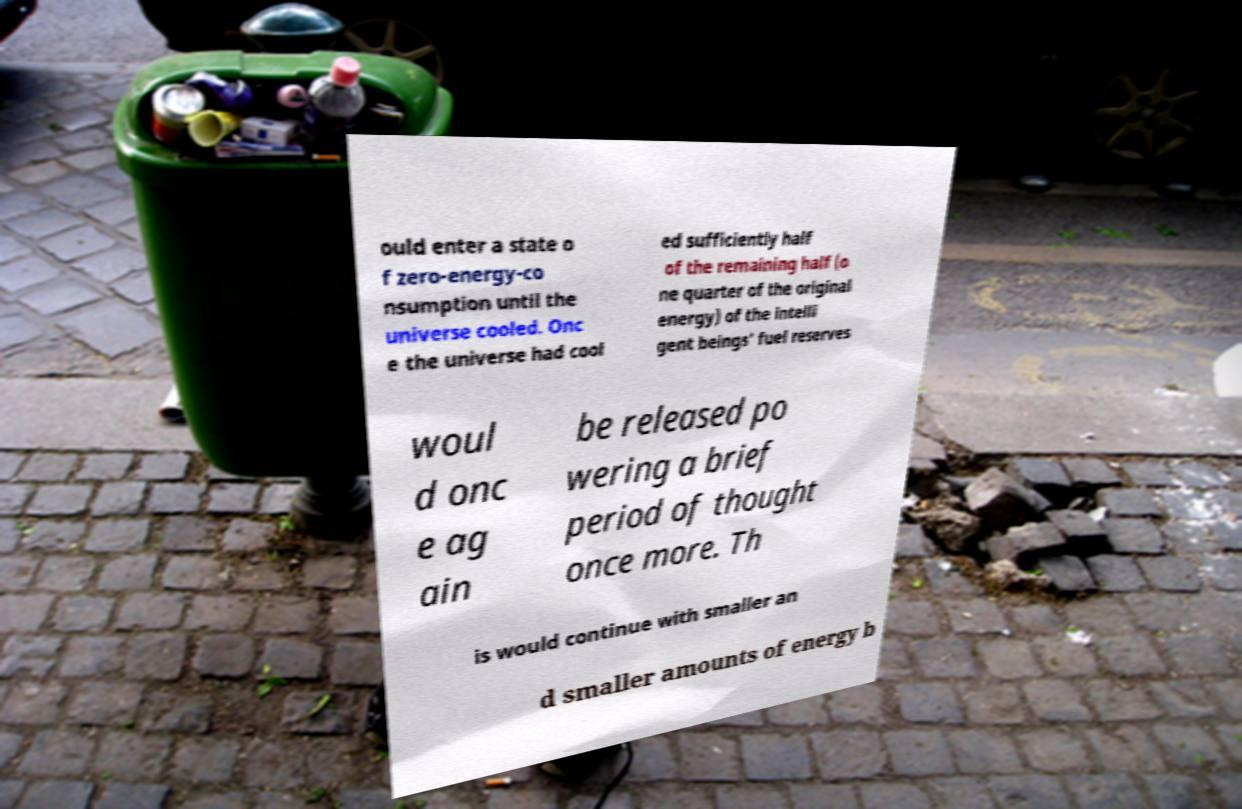Could you extract and type out the text from this image? ould enter a state o f zero-energy-co nsumption until the universe cooled. Onc e the universe had cool ed sufficiently half of the remaining half (o ne quarter of the original energy) of the intelli gent beings' fuel reserves woul d onc e ag ain be released po wering a brief period of thought once more. Th is would continue with smaller an d smaller amounts of energy b 